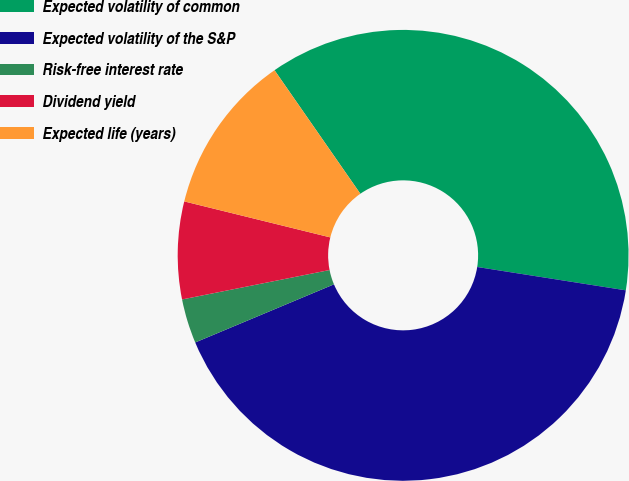Convert chart. <chart><loc_0><loc_0><loc_500><loc_500><pie_chart><fcel>Expected volatility of common<fcel>Expected volatility of the S&P<fcel>Risk-free interest rate<fcel>Dividend yield<fcel>Expected life (years)<nl><fcel>37.14%<fcel>41.2%<fcel>3.18%<fcel>6.98%<fcel>11.49%<nl></chart> 